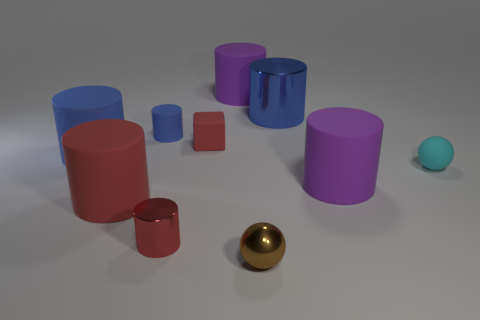There is a metallic cylinder that is to the left of the brown metal thing; is its color the same as the small cube?
Your answer should be compact. Yes. What number of things are either small matte things that are on the left side of the red metallic cylinder or small objects to the left of the small red cylinder?
Give a very brief answer. 1. Are there any large matte cylinders right of the cyan matte object?
Offer a terse response. No. What number of things are either tiny spheres that are behind the tiny brown metallic thing or gray blocks?
Provide a short and direct response. 1. What number of cyan objects are either small rubber balls or small cylinders?
Ensure brevity in your answer.  1. What number of other things are there of the same color as the small cube?
Make the answer very short. 2. Is the number of shiny things left of the brown shiny sphere less than the number of big red cylinders?
Give a very brief answer. No. What color is the metal cylinder right of the tiny cylinder in front of the blue cylinder that is in front of the tiny block?
Offer a terse response. Blue. What is the size of the other object that is the same shape as the small brown thing?
Your answer should be compact. Small. Are there fewer blue matte cylinders that are on the right side of the tiny matte block than red shiny things that are behind the tiny red metallic object?
Your response must be concise. No. 